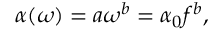Convert formula to latex. <formula><loc_0><loc_0><loc_500><loc_500>\alpha ( \omega ) = a \omega ^ { b } = \alpha _ { 0 } f ^ { b } ,</formula> 